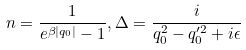Convert formula to latex. <formula><loc_0><loc_0><loc_500><loc_500>n = \frac { 1 } { e ^ { \beta | q _ { 0 } | } - 1 } , \Delta = \frac { i } { q _ { 0 } ^ { 2 } - q _ { 0 } ^ { \prime 2 } + i \epsilon }</formula> 